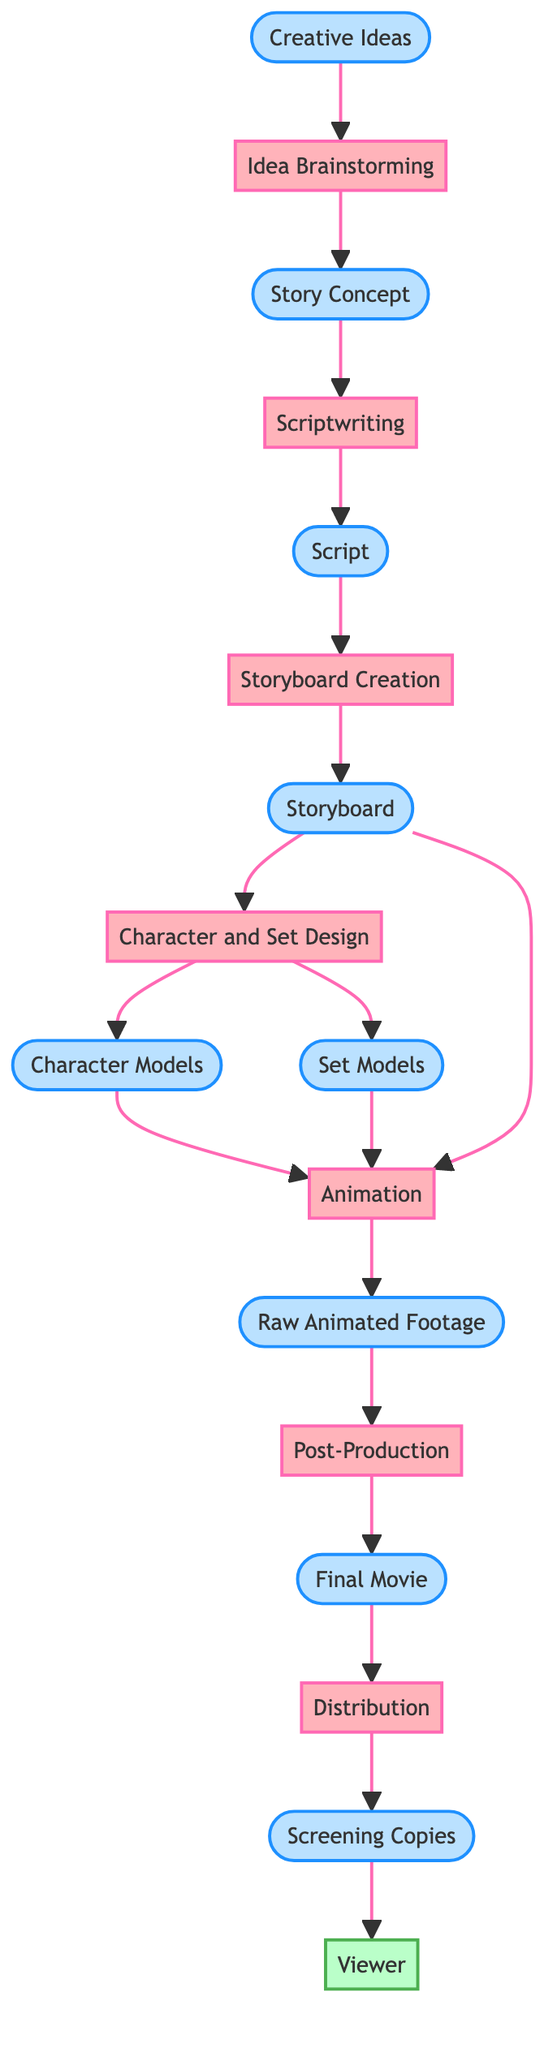What is the first process in the diagram? The first process depicted in the diagram is "Idea Brainstorming," which follows the initial input of "Creative Ideas." By tracing the arrows from the initial input to the first process, we can identify it as the starting point of the production process.
Answer: Idea Brainstorming How many main processes are shown in the diagram? The diagram presents a total of seven main processes, including Idea Brainstorming, Scriptwriting, Storyboard Creation, Character and Set Design, Animation, Post-Production, and Distribution. By counting the processes listed, we determine the overall number.
Answer: Seven What is the output of the Scriptwriting process? The output of the Scriptwriting process is the "Script," which is generated based on the input from the "Story Concept." By reviewing the output listed for each process, we confirm the answer.
Answer: Script Which process directly follows Post-Production? The process that directly follows Post-Production is "Distribution." This can be established by following the arrow from Post-Production to its direct successor in the diagram.
Answer: Distribution What are the outputs of the Character and Set Design process? The outputs of the Character and Set Design process are "Character Models" and "Set Models." By examining the output connected to this particular process, we find these two outputs listed.
Answer: Character Models, Set Models What is the final output of the entire production process? The final output of the entire production process is the "Screening Copies," which is derived from the "Final Movie" during the Distribution process. By identifying the last process and its output in the flow, we observe this conclusion.
Answer: Screening Copies How does the Raw Animated Footage relate to the final movie? The Raw Animated Footage is the input to the Post-Production process, which then produces the Final Movie. By following the flow from Raw Animated Footage to Post-Production and onto its outcome, we see how these two are interconnected.
Answer: Input to the Post-Production Which external entity is involved at the end of the process? The external entity involved at the end of the process is the "Viewer." This information can be found at the final stage of the flow, where Screening Copies are directed to the Viewer.
Answer: Viewer 